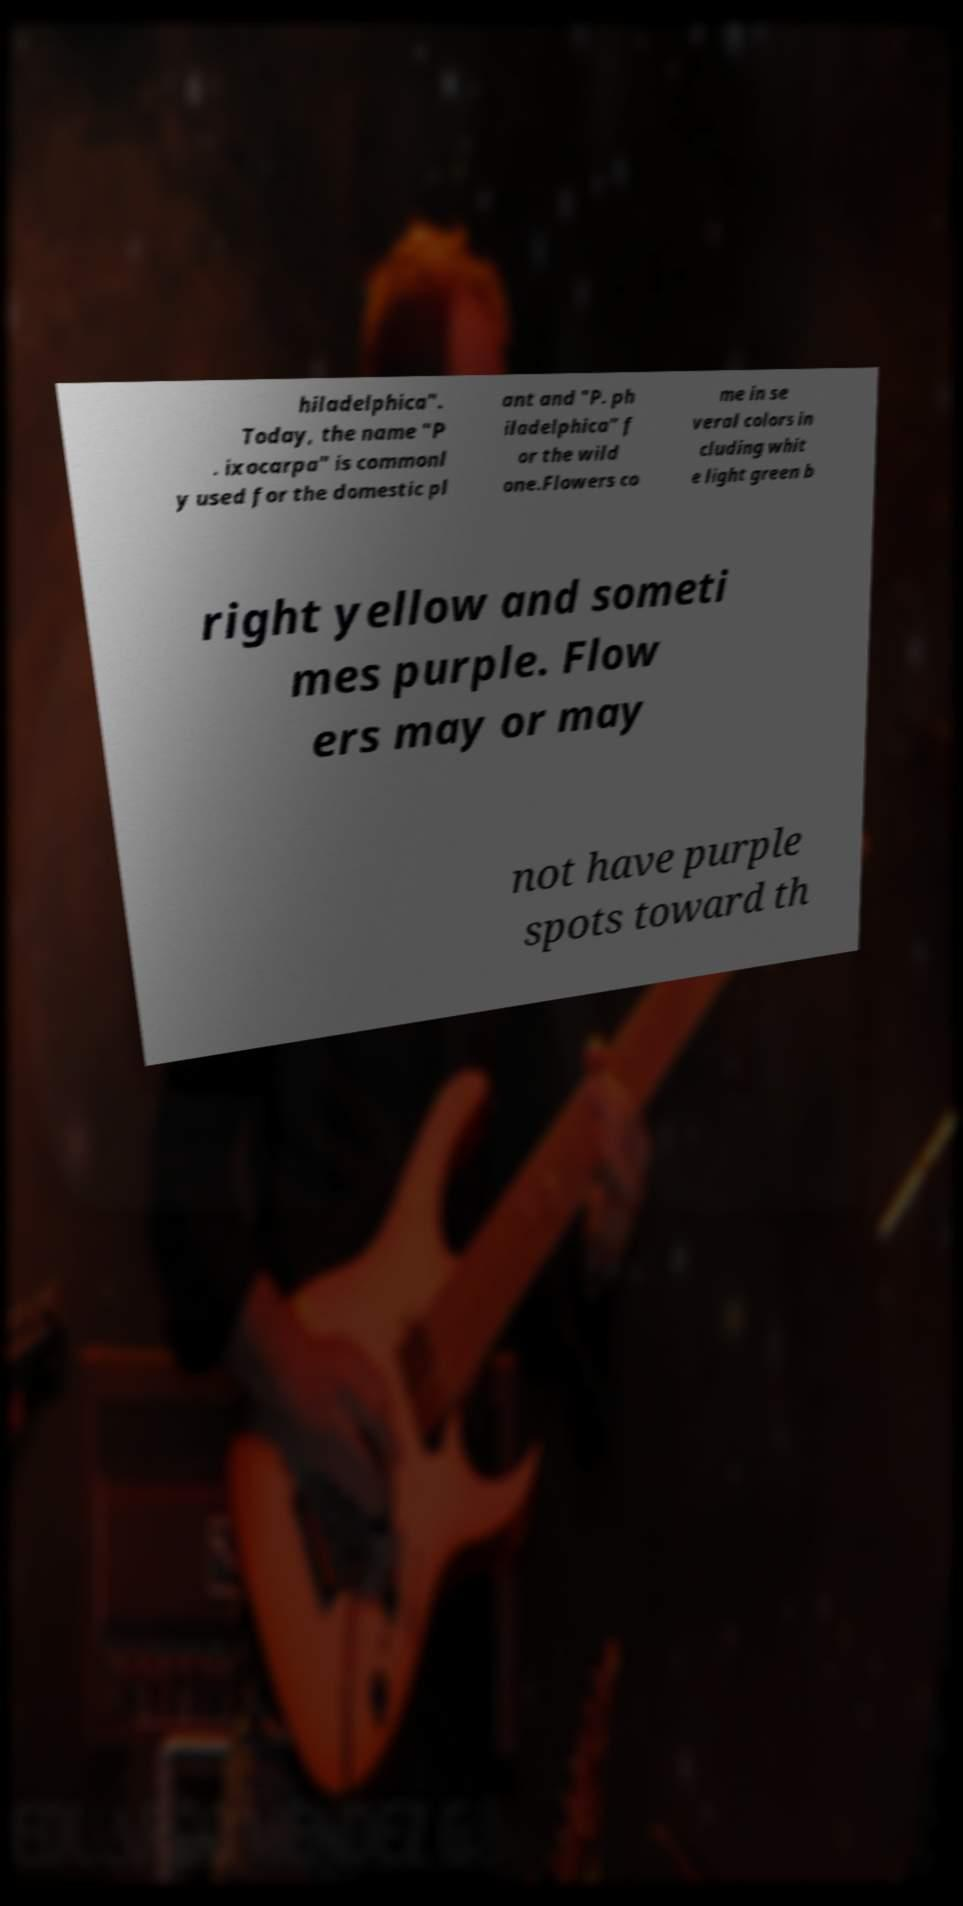Could you extract and type out the text from this image? hiladelphica". Today, the name "P . ixocarpa" is commonl y used for the domestic pl ant and "P. ph iladelphica" f or the wild one.Flowers co me in se veral colors in cluding whit e light green b right yellow and someti mes purple. Flow ers may or may not have purple spots toward th 